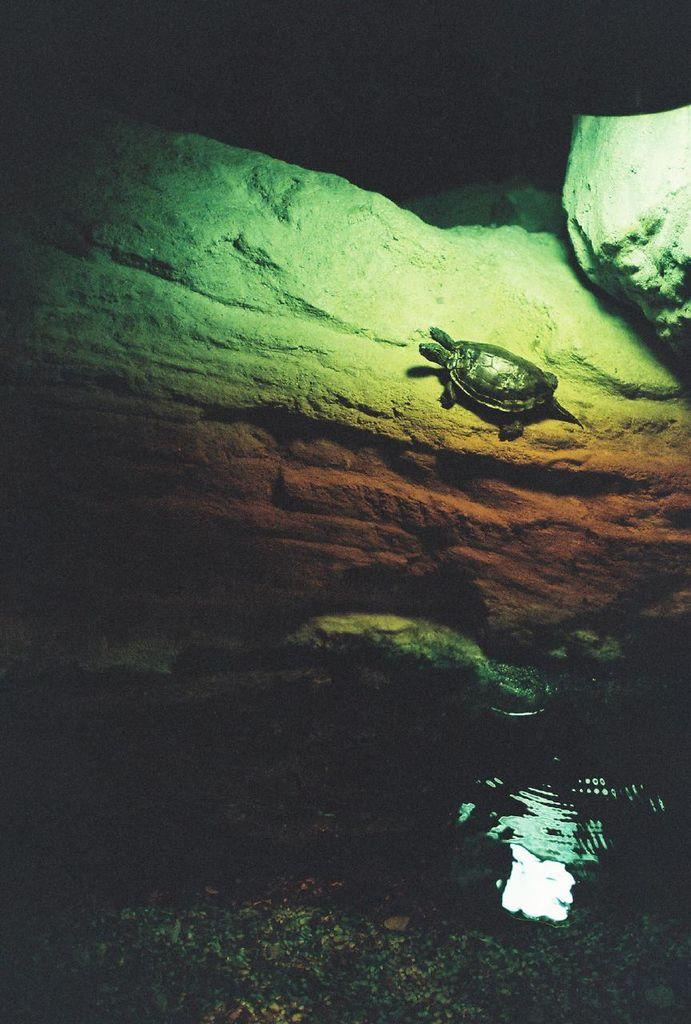What animal can be seen in the image? There is a turtle on a rock in the image. What is the turtle sitting on? The turtle is sitting on a rock. What can be seen at the bottom of the image? There is water visible at the bottom of the image. What is the color of the background in the image? The background of the image is dark. How does the turtle control the motion of the bubbles in the image? There are no bubbles present in the image, so the turtle cannot control their motion. 